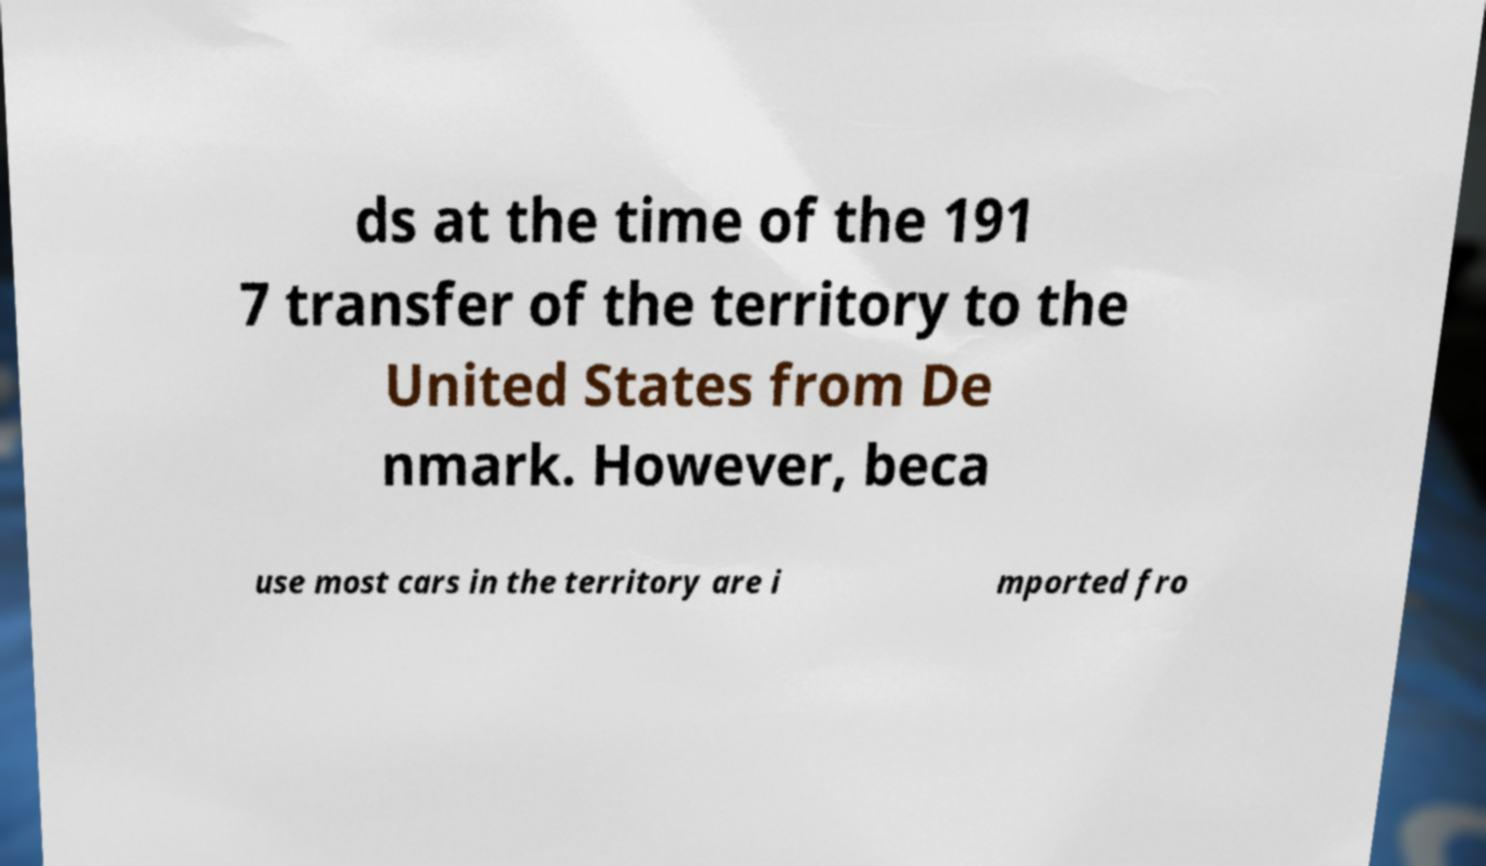Can you read and provide the text displayed in the image?This photo seems to have some interesting text. Can you extract and type it out for me? ds at the time of the 191 7 transfer of the territory to the United States from De nmark. However, beca use most cars in the territory are i mported fro 